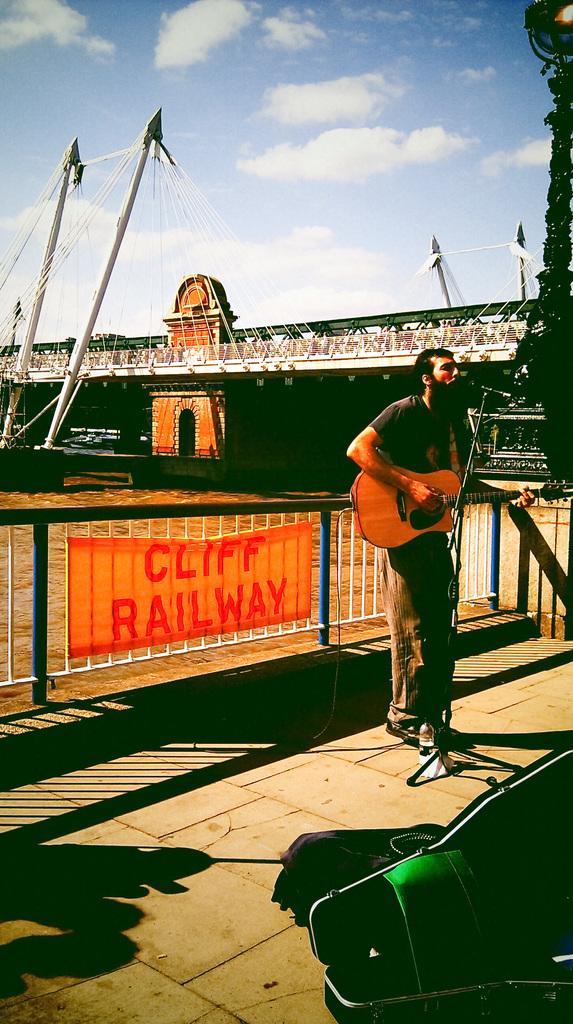In one or two sentences, can you explain what this image depicts? In this picture we can see man standing and holding guitar in his hand and playing it and singing on mic and in background we can see fence, banner, bridge, pole, sky with clouds. 